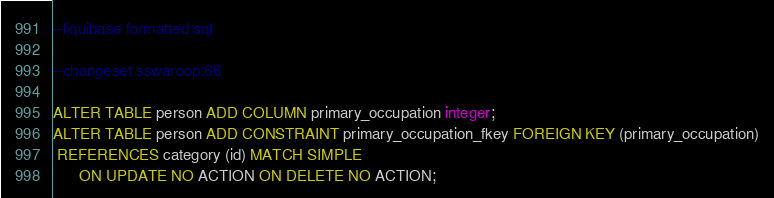Convert code to text. <code><loc_0><loc_0><loc_500><loc_500><_SQL_>--liquibase formatted sql 

--changeset sswaroop:66

ALTER TABLE person ADD COLUMN primary_occupation integer;
ALTER TABLE person ADD CONSTRAINT primary_occupation_fkey FOREIGN KEY (primary_occupation)
 REFERENCES category (id) MATCH SIMPLE
      ON UPDATE NO ACTION ON DELETE NO ACTION;</code> 